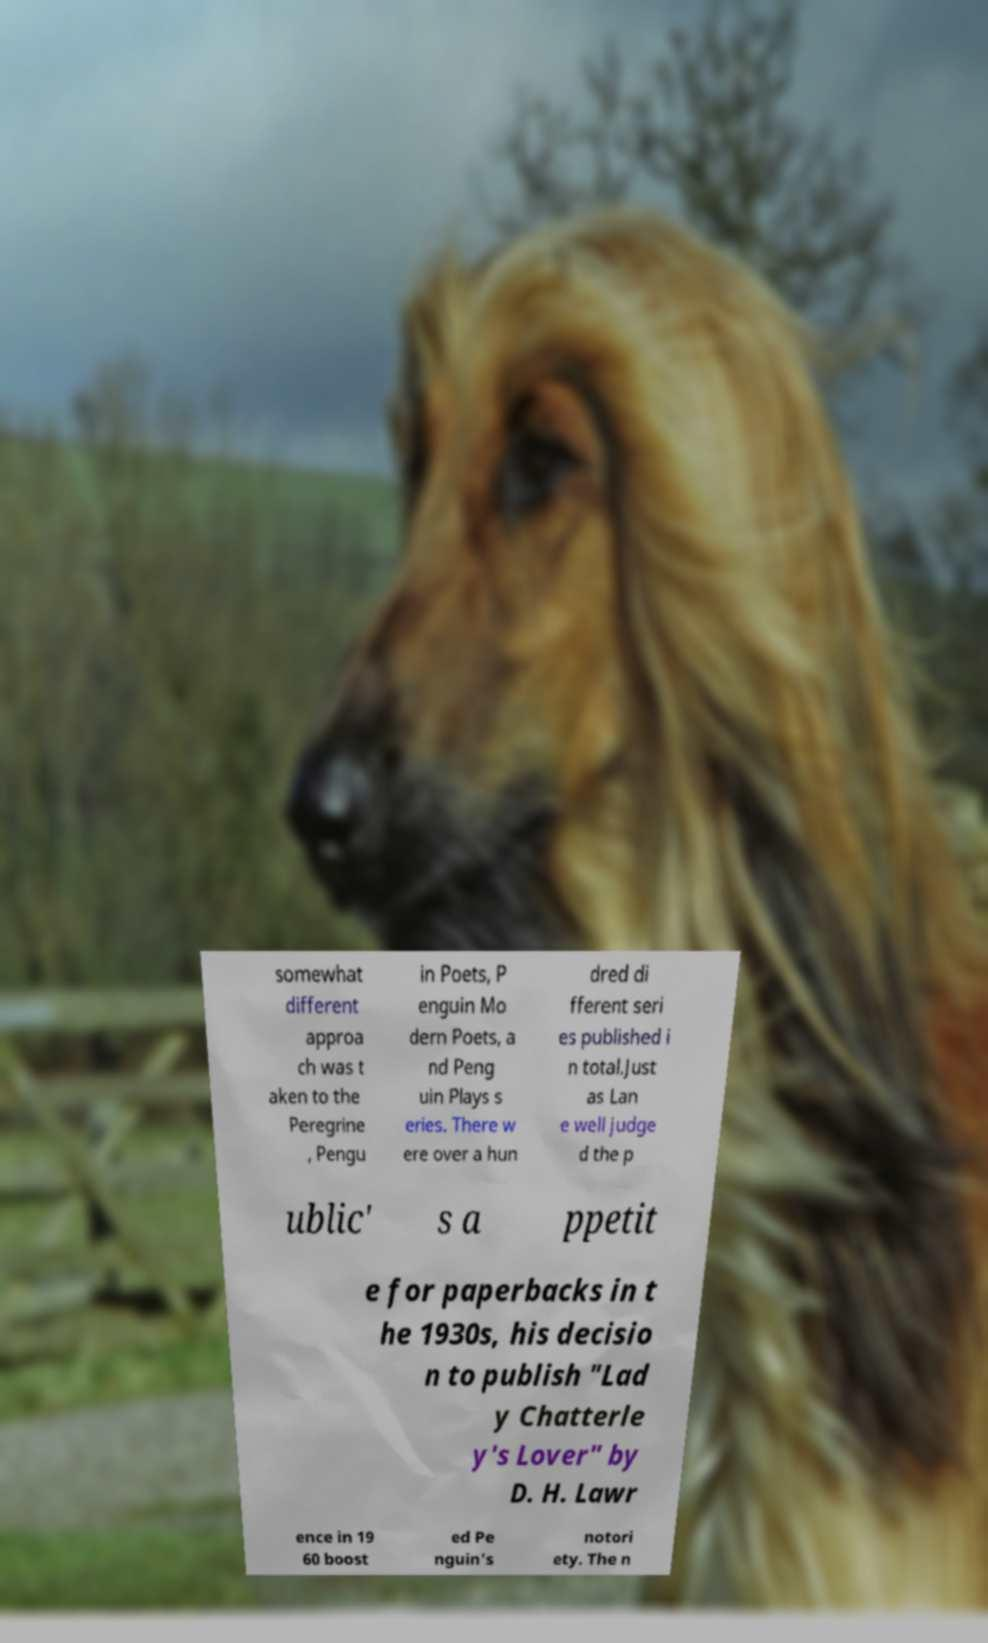There's text embedded in this image that I need extracted. Can you transcribe it verbatim? somewhat different approa ch was t aken to the Peregrine , Pengu in Poets, P enguin Mo dern Poets, a nd Peng uin Plays s eries. There w ere over a hun dred di fferent seri es published i n total.Just as Lan e well judge d the p ublic' s a ppetit e for paperbacks in t he 1930s, his decisio n to publish "Lad y Chatterle y's Lover" by D. H. Lawr ence in 19 60 boost ed Pe nguin's notori ety. The n 